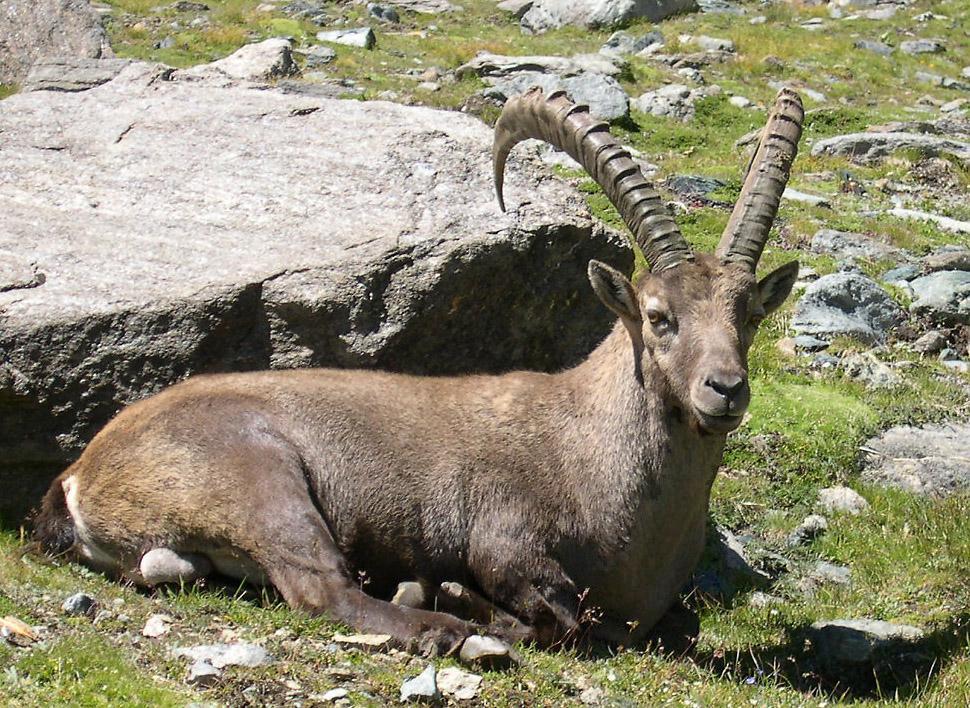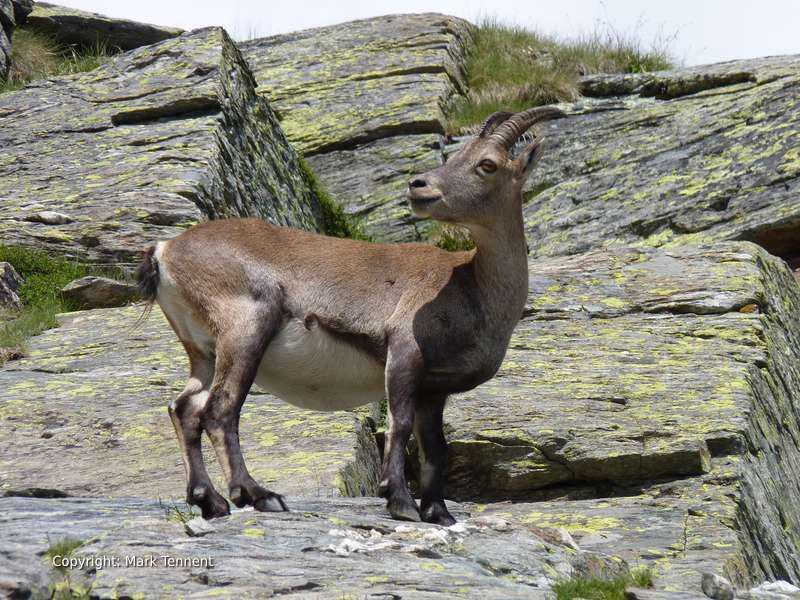The first image is the image on the left, the second image is the image on the right. For the images displayed, is the sentence "There is snow visible." factually correct? Answer yes or no. No. 